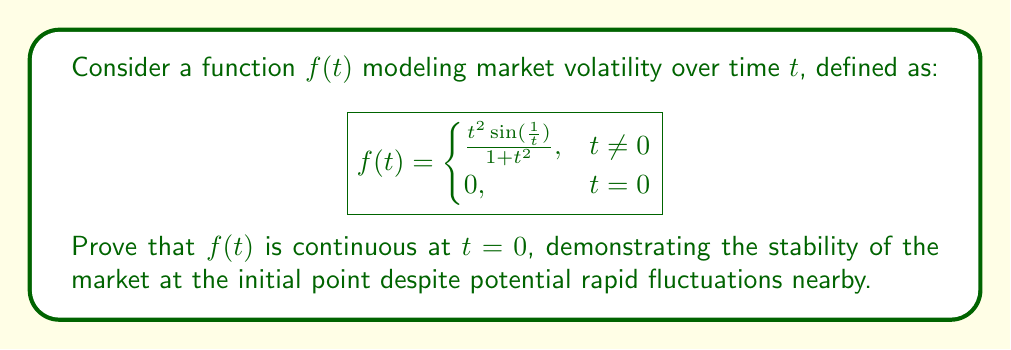Could you help me with this problem? To prove the continuity of $f(t)$ at $t = 0$, we need to show that $\lim_{t \to 0} f(t) = f(0)$. Let's approach this step-by-step:

1) First, note that $f(0) = 0$ by definition.

2) Now, let's consider $\lim_{t \to 0} f(t)$ for $t \neq 0$:

   $$\lim_{t \to 0} f(t) = \lim_{t \to 0} \frac{t^2 \sin(\frac{1}{t})}{1 + t^2}$$

3) To evaluate this limit, we can use the squeeze theorem. Let's bound $f(t)$:

   $$\left|\frac{t^2 \sin(\frac{1}{t})}{1 + t^2}\right| \leq \frac{|t^2|}{1 + t^2}$$

   This is because $|\sin(\frac{1}{t})| \leq 1$ for all $t \neq 0$.

4) Now, let's consider the limit of the right-hand side:

   $$\lim_{t \to 0} \frac{|t^2|}{1 + t^2} = \lim_{t \to 0} \frac{t^2}{1 + t^2} = 0$$

5) By the squeeze theorem, since:

   $$0 \leq \left|\frac{t^2 \sin(\frac{1}{t})}{1 + t^2}\right| \leq \frac{t^2}{1 + t^2}$$

   and $\lim_{t \to 0} \frac{t^2}{1 + t^2} = 0$, we can conclude:

   $$\lim_{t \to 0} \frac{t^2 \sin(\frac{1}{t})}{1 + t^2} = 0$$

6) Therefore, $\lim_{t \to 0} f(t) = 0 = f(0)$

Thus, we have shown that $\lim_{t \to 0} f(t) = f(0)$, proving that $f(t)$ is continuous at $t = 0$.
Answer: The function $f(t)$ is continuous at $t = 0$ because $\lim_{t \to 0} f(t) = f(0) = 0$, as proven using the squeeze theorem. 